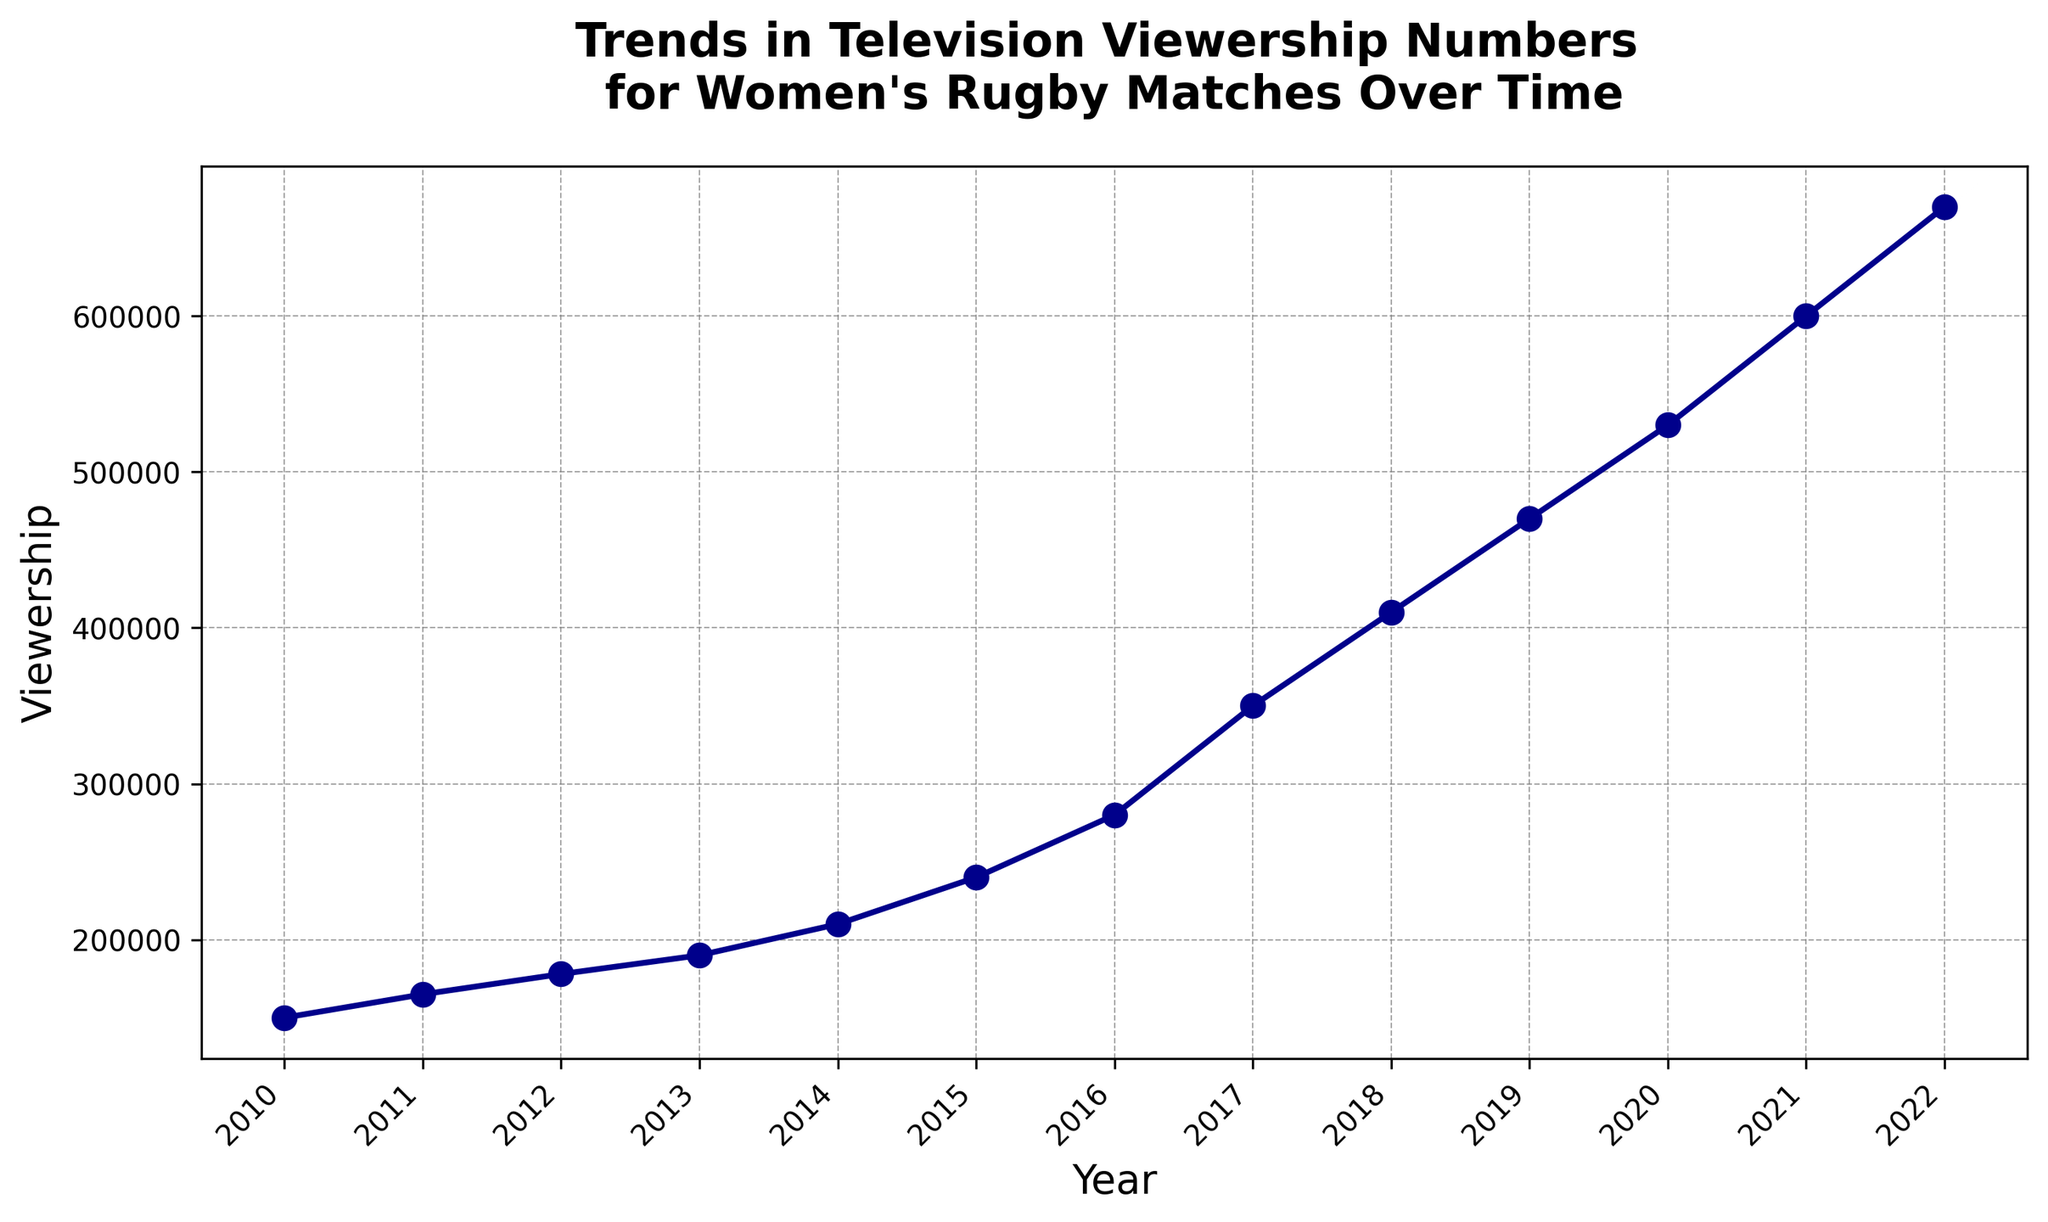What is the viewership in 2015? Referring to the plot, locate the point corresponding to the year 2015 on the x-axis and observe the corresponding y-value.
Answer: 240000 Which year showed the highest increase in viewership from the previous year? Compare the yearly increases in viewership and identify the year with the largest difference between consecutive years. The largest increase is from 2016 to 2017.
Answer: 2017 How much did the viewership increase between 2010 and 2022? Calculate the difference in viewership between 2022 and 2010. The values are 670000 for 2022 and 150000 for 2010, so the increase is 670000 - 150000.
Answer: 520000 Compare the viewership in 2018 and 2019. Which year had higher viewership? Locate the points for the years 2018 and 2019 on the x-axis and compare their corresponding y-values. 2019 has a higher viewership (470000) than 2018 (410000).
Answer: 2019 What is the average viewership between 2010 and 2015? Sum the viewership numbers from 2010 to 2015 (150000 + 165000 + 178000 + 190000 + 210000 + 240000) and divide by the number of years (6) to get the average.
Answer: 188833.33 By how much did the viewership increase from 2014 to 2015? Subtract the viewership in 2014 (210000) from the viewership in 2015 (240000).
Answer: 30000 Did the viewership ever decrease between consecutive years? Examine the trend line of the plot to see if there are any downward slopes between consecutive data points. There are no decreases; the viewership steadily increases each year.
Answer: No What is the median viewership for the years 2010 to 2022? Organize the viewership numbers from 2010 to 2022 in ascending order and find the median, which is the middle value or the average of the two middle values. For 13 data points, the median is the 7th value.
Answer: 280000 What was the percentage increase in viewership from 2020 to 2021? Calculate the difference in viewership between 2020 (530000) and 2021 (600000), then divide by the 2020 viewership and multiply by 100 to get the percentage. ((600000 - 530000) / 530000) * 100
Answer: 13.21% In which year did the viewership first exceed 300000? Locate the point on the x-axis where the y-value first surpasses 300000. This occurs in 2017.
Answer: 2017 